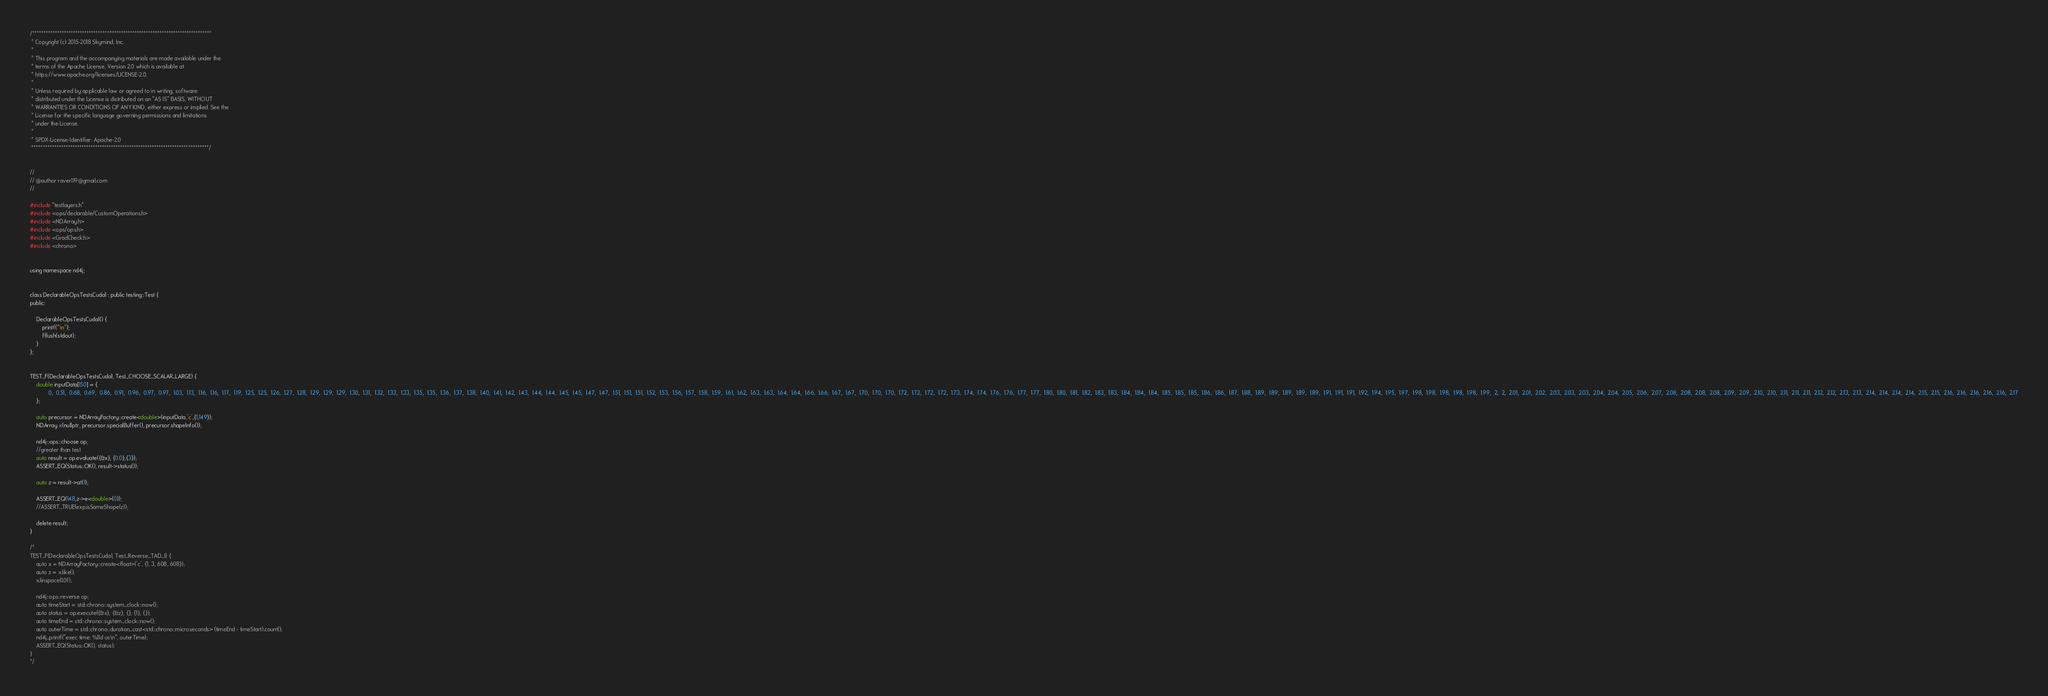Convert code to text. <code><loc_0><loc_0><loc_500><loc_500><_Cuda_>/*******************************************************************************
 * Copyright (c) 2015-2018 Skymind, Inc.
 *
 * This program and the accompanying materials are made available under the
 * terms of the Apache License, Version 2.0 which is available at
 * https://www.apache.org/licenses/LICENSE-2.0.
 *
 * Unless required by applicable law or agreed to in writing, software
 * distributed under the License is distributed on an "AS IS" BASIS, WITHOUT
 * WARRANTIES OR CONDITIONS OF ANY KIND, either express or implied. See the
 * License for the specific language governing permissions and limitations
 * under the License.
 *
 * SPDX-License-Identifier: Apache-2.0
 ******************************************************************************/


//
// @author raver119@gmail.com
//

#include "testlayers.h"
#include <ops/declarable/CustomOperations.h>
#include <NDArray.h>
#include <ops/ops.h>
#include <GradCheck.h>
#include <chrono>


using namespace nd4j;


class DeclarableOpsTestsCuda1 : public testing::Test {
public:

    DeclarableOpsTestsCuda1() {
        printf("\n");
        fflush(stdout);
    }
};


TEST_F(DeclarableOpsTestsCuda1, Test_CHOOSE_SCALAR_LARGE) {
    double inputData[150] = {
            0,  0.51,  0.68,  0.69,  0.86,  0.91,  0.96,  0.97,  0.97,  1.03,  1.13,  1.16,  1.16,  1.17,  1.19,  1.25,  1.25,  1.26,  1.27,  1.28,  1.29,  1.29,  1.29,  1.30,  1.31,  1.32,  1.33,  1.33,  1.35,  1.35,  1.36,  1.37,  1.38,  1.40,  1.41,  1.42,  1.43,  1.44,  1.44,  1.45,  1.45,  1.47,  1.47,  1.51,  1.51,  1.51,  1.52,  1.53,  1.56,  1.57,  1.58,  1.59,  1.61,  1.62,  1.63,  1.63,  1.64,  1.64,  1.66,  1.66,  1.67,  1.67,  1.70,  1.70,  1.70,  1.72,  1.72,  1.72,  1.72,  1.73,  1.74,  1.74,  1.76,  1.76,  1.77,  1.77,  1.80,  1.80,  1.81,  1.82,  1.83,  1.83,  1.84,  1.84,  1.84,  1.85,  1.85,  1.85,  1.86,  1.86,  1.87,  1.88,  1.89,  1.89,  1.89,  1.89,  1.89,  1.91,  1.91,  1.91,  1.92,  1.94,  1.95,  1.97,  1.98,  1.98,  1.98,  1.98,  1.98,  1.99,  2,  2,  2.01,  2.01,  2.02,  2.03,  2.03,  2.03,  2.04,  2.04,  2.05,  2.06,  2.07,  2.08,  2.08,  2.08,  2.08,  2.09,  2.09,  2.10,  2.10,  2.11,  2.11,  2.11,  2.12,  2.12,  2.13,  2.13,  2.14,  2.14,  2.14,  2.14,  2.15,  2.15,  2.16,  2.16,  2.16,  2.16,  2.16,  2.17
    };

    auto precursor = NDArrayFactory::create<double>(inputData,'c',{1,149});
    NDArray x(nullptr, precursor.specialBuffer(), precursor.shapeInfo());

    nd4j::ops::choose op;
    //greater than test
    auto result = op.evaluate({&x}, {0.0},{3});
    ASSERT_EQ(Status::OK(), result->status());

    auto z = result->at(1);

    ASSERT_EQ(148,z->e<double>(0));
    //ASSERT_TRUE(exp.isSameShape(z));

    delete result;
}

/*
TEST_F(DeclarableOpsTestsCuda1, Test_Reverse_TAD_1) {
    auto x = NDArrayFactory::create<float>('c', {1, 3, 608, 608});
    auto z = x.like();
    x.linspace(1.0f);

    nd4j::ops::reverse op;
    auto timeStart = std::chrono::system_clock::now();
    auto status = op.execute({&x}, {&z}, {}, {1}, {});
    auto timeEnd = std::chrono::system_clock::now();
    auto outerTime = std::chrono::duration_cast<std::chrono::microseconds> (timeEnd - timeStart).count();
    nd4j_printf("exec time: %lld us\n", outerTime);
    ASSERT_EQ(Status::OK(), status);
}
*/</code> 